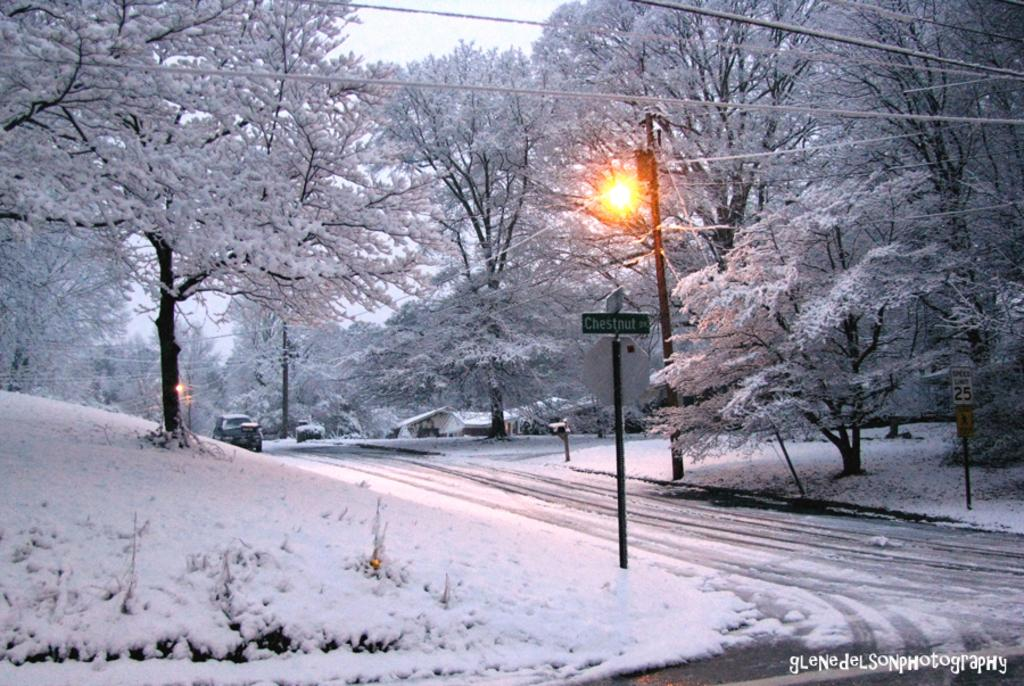What type of natural elements can be seen in the image? There are trees in the image. What man-made structures are present in the image? Street poles, street lights, electric cables, name boards, and a road are visible in the image. How is the image affected by the weather? All elements mentioned are covered with snow. What part of the natural environment is visible in the background of the image? The sky is visible in the background of the image. Can you see any army personnel or vehicles in the image? No, there is no army personnel or vehicles present in the image. Are there any cornfields visible in the image? No, there are no cornfields present in the image. 